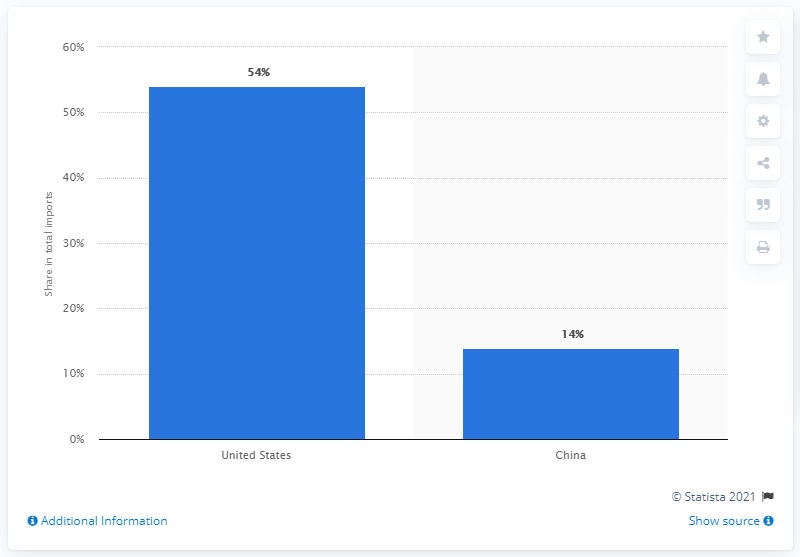Identify some key points in this picture. In 2019, the United States accounted for approximately 54% of total imports. 